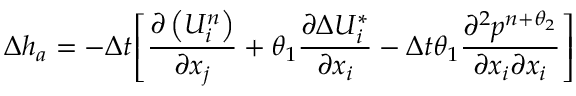Convert formula to latex. <formula><loc_0><loc_0><loc_500><loc_500>\Delta { { h } _ { a } } = - \Delta t { { \left [ \frac { \partial \left ( U _ { i } ^ { n } \right ) } { \partial { { x } _ { j } } } + { { \theta } _ { 1 } } \frac { \partial \Delta U _ { i } ^ { * } } { \partial { { x } _ { i } } } - \Delta t { { \theta } _ { 1 } } \frac { { { \partial } ^ { 2 } } { { p } ^ { n + { { \theta } _ { 2 } } } } } { \partial { { x } _ { i } } \partial { { x } _ { i } } } \right ] } }</formula> 